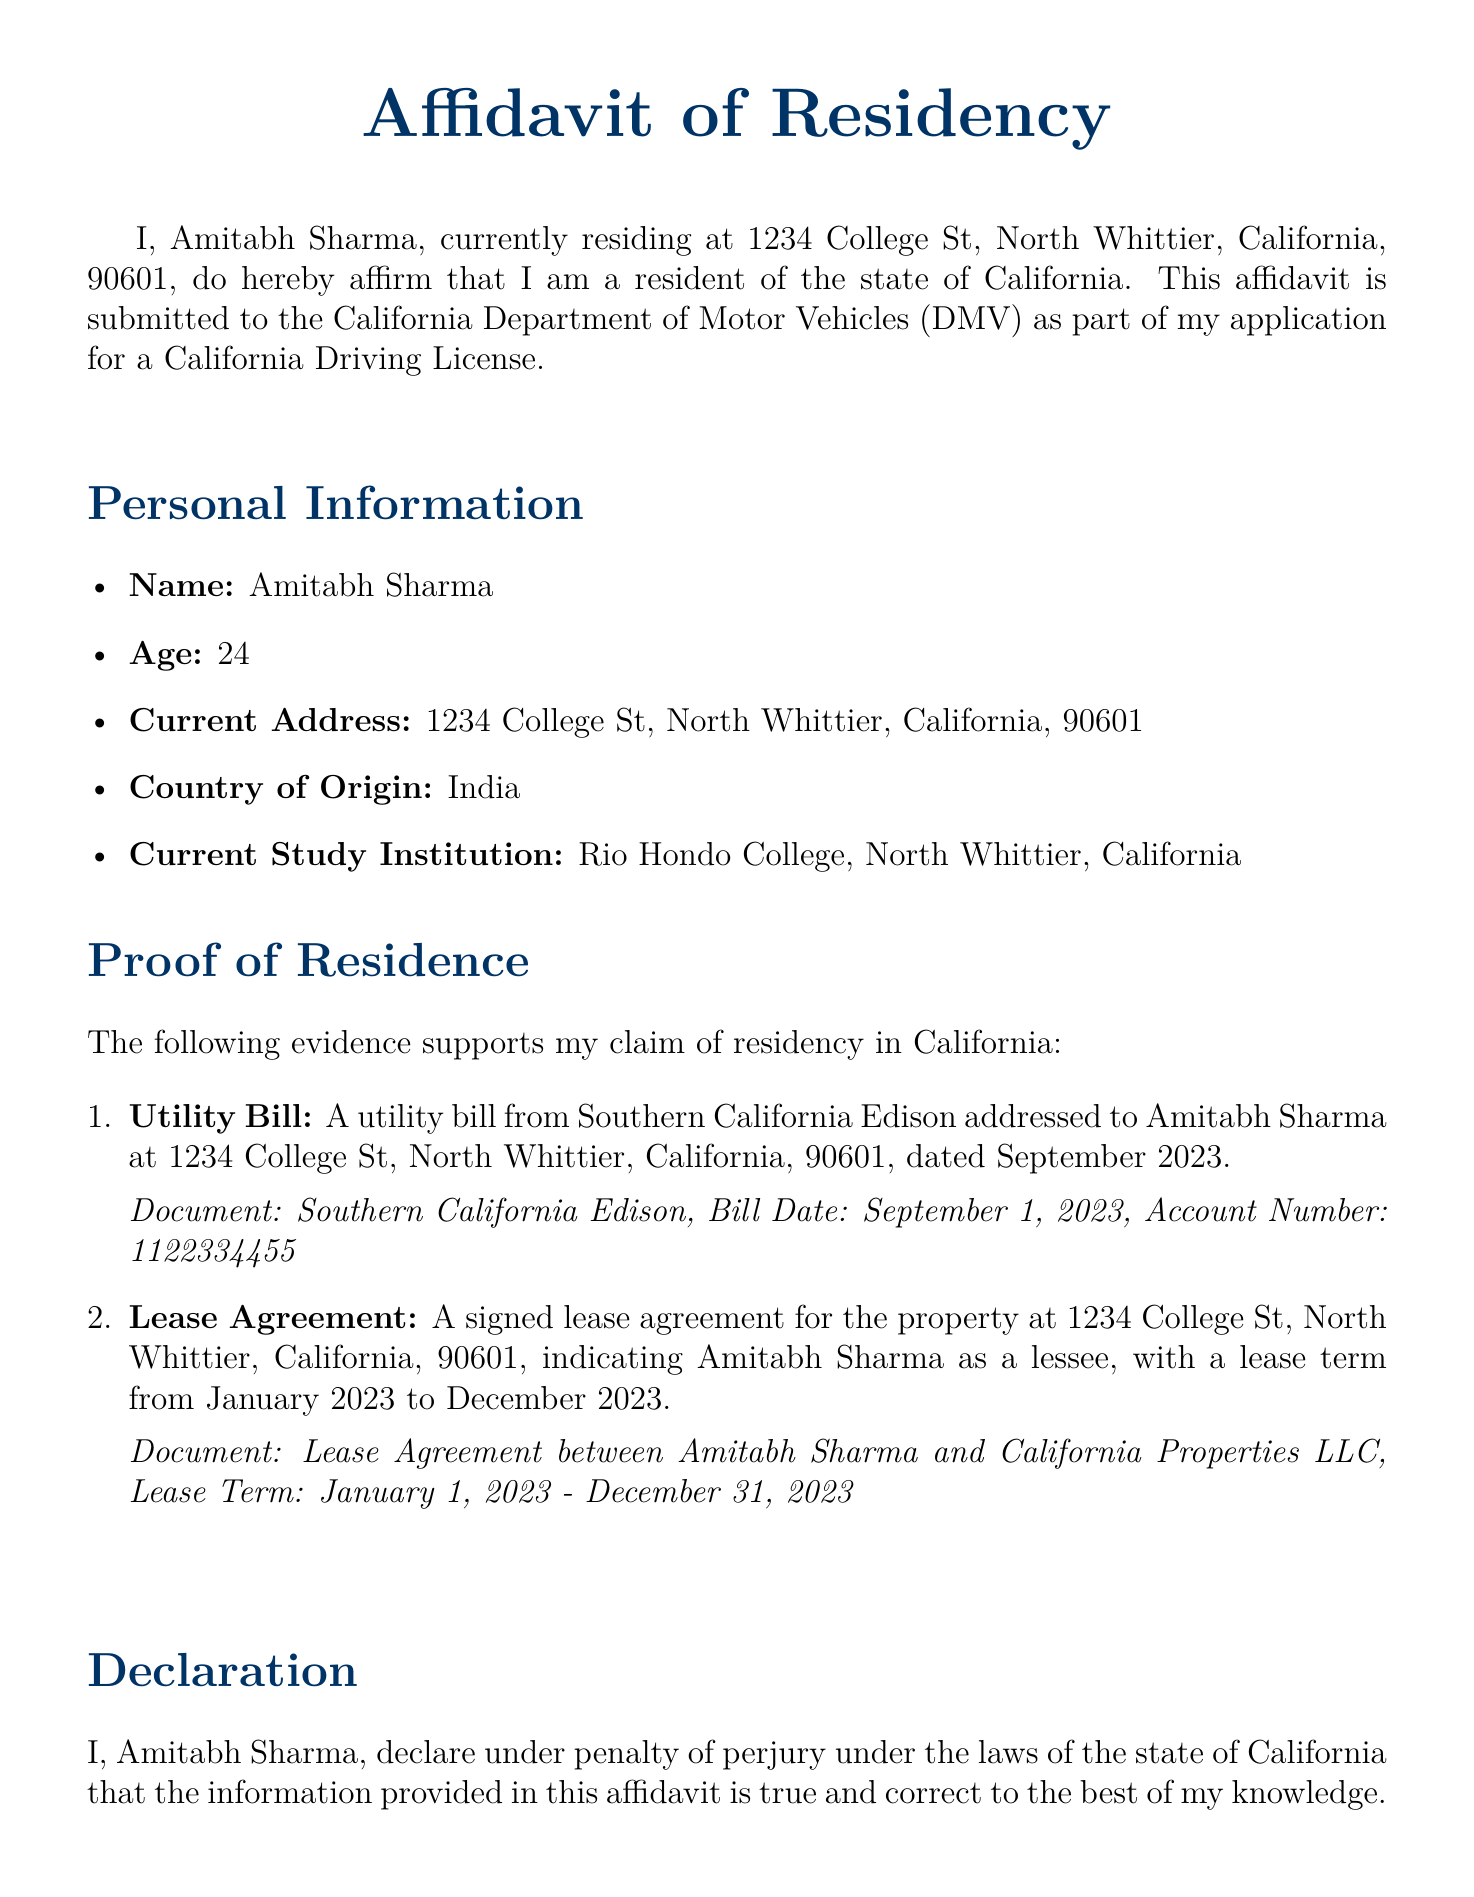What is the name of the affiant? The affiant's name is stated at the beginning of the document as the person making the affidavit.
Answer: Amitabh Sharma What is the current address of the affiant? The current address is specified as the place where the affiant resides.
Answer: 1234 College St, North Whittier, California, 90601 What utility company's bill is included as proof of residence? The document mentions a utility bill as evidence of residency, referring to a specific company.
Answer: Southern California Edison What is the lease agreement term? The lease agreement indicates the duration of the lease, providing start and end dates.
Answer: January 1, 2023 - December 31, 2023 When was the utility bill issued? The date of the utility bill is provided as part of the evidence supporting residency.
Answer: September 1, 2023 What penalty does the affiant face for providing false information? The document specifies the consequences of providing incorrect information as part of a legal declaration.
Answer: Perjury How old is the affiant? The document explicitly states the age of the affiant for identification purposes.
Answer: 24 What is the purpose of the affidavit? The document outlines the reason for submitting the affidavit to the authorities.
Answer: California Driving License Application 